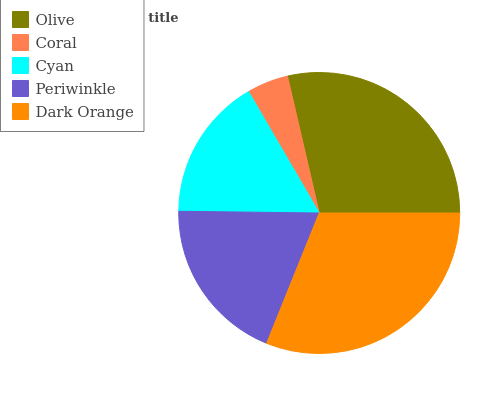Is Coral the minimum?
Answer yes or no. Yes. Is Dark Orange the maximum?
Answer yes or no. Yes. Is Cyan the minimum?
Answer yes or no. No. Is Cyan the maximum?
Answer yes or no. No. Is Cyan greater than Coral?
Answer yes or no. Yes. Is Coral less than Cyan?
Answer yes or no. Yes. Is Coral greater than Cyan?
Answer yes or no. No. Is Cyan less than Coral?
Answer yes or no. No. Is Periwinkle the high median?
Answer yes or no. Yes. Is Periwinkle the low median?
Answer yes or no. Yes. Is Dark Orange the high median?
Answer yes or no. No. Is Olive the low median?
Answer yes or no. No. 